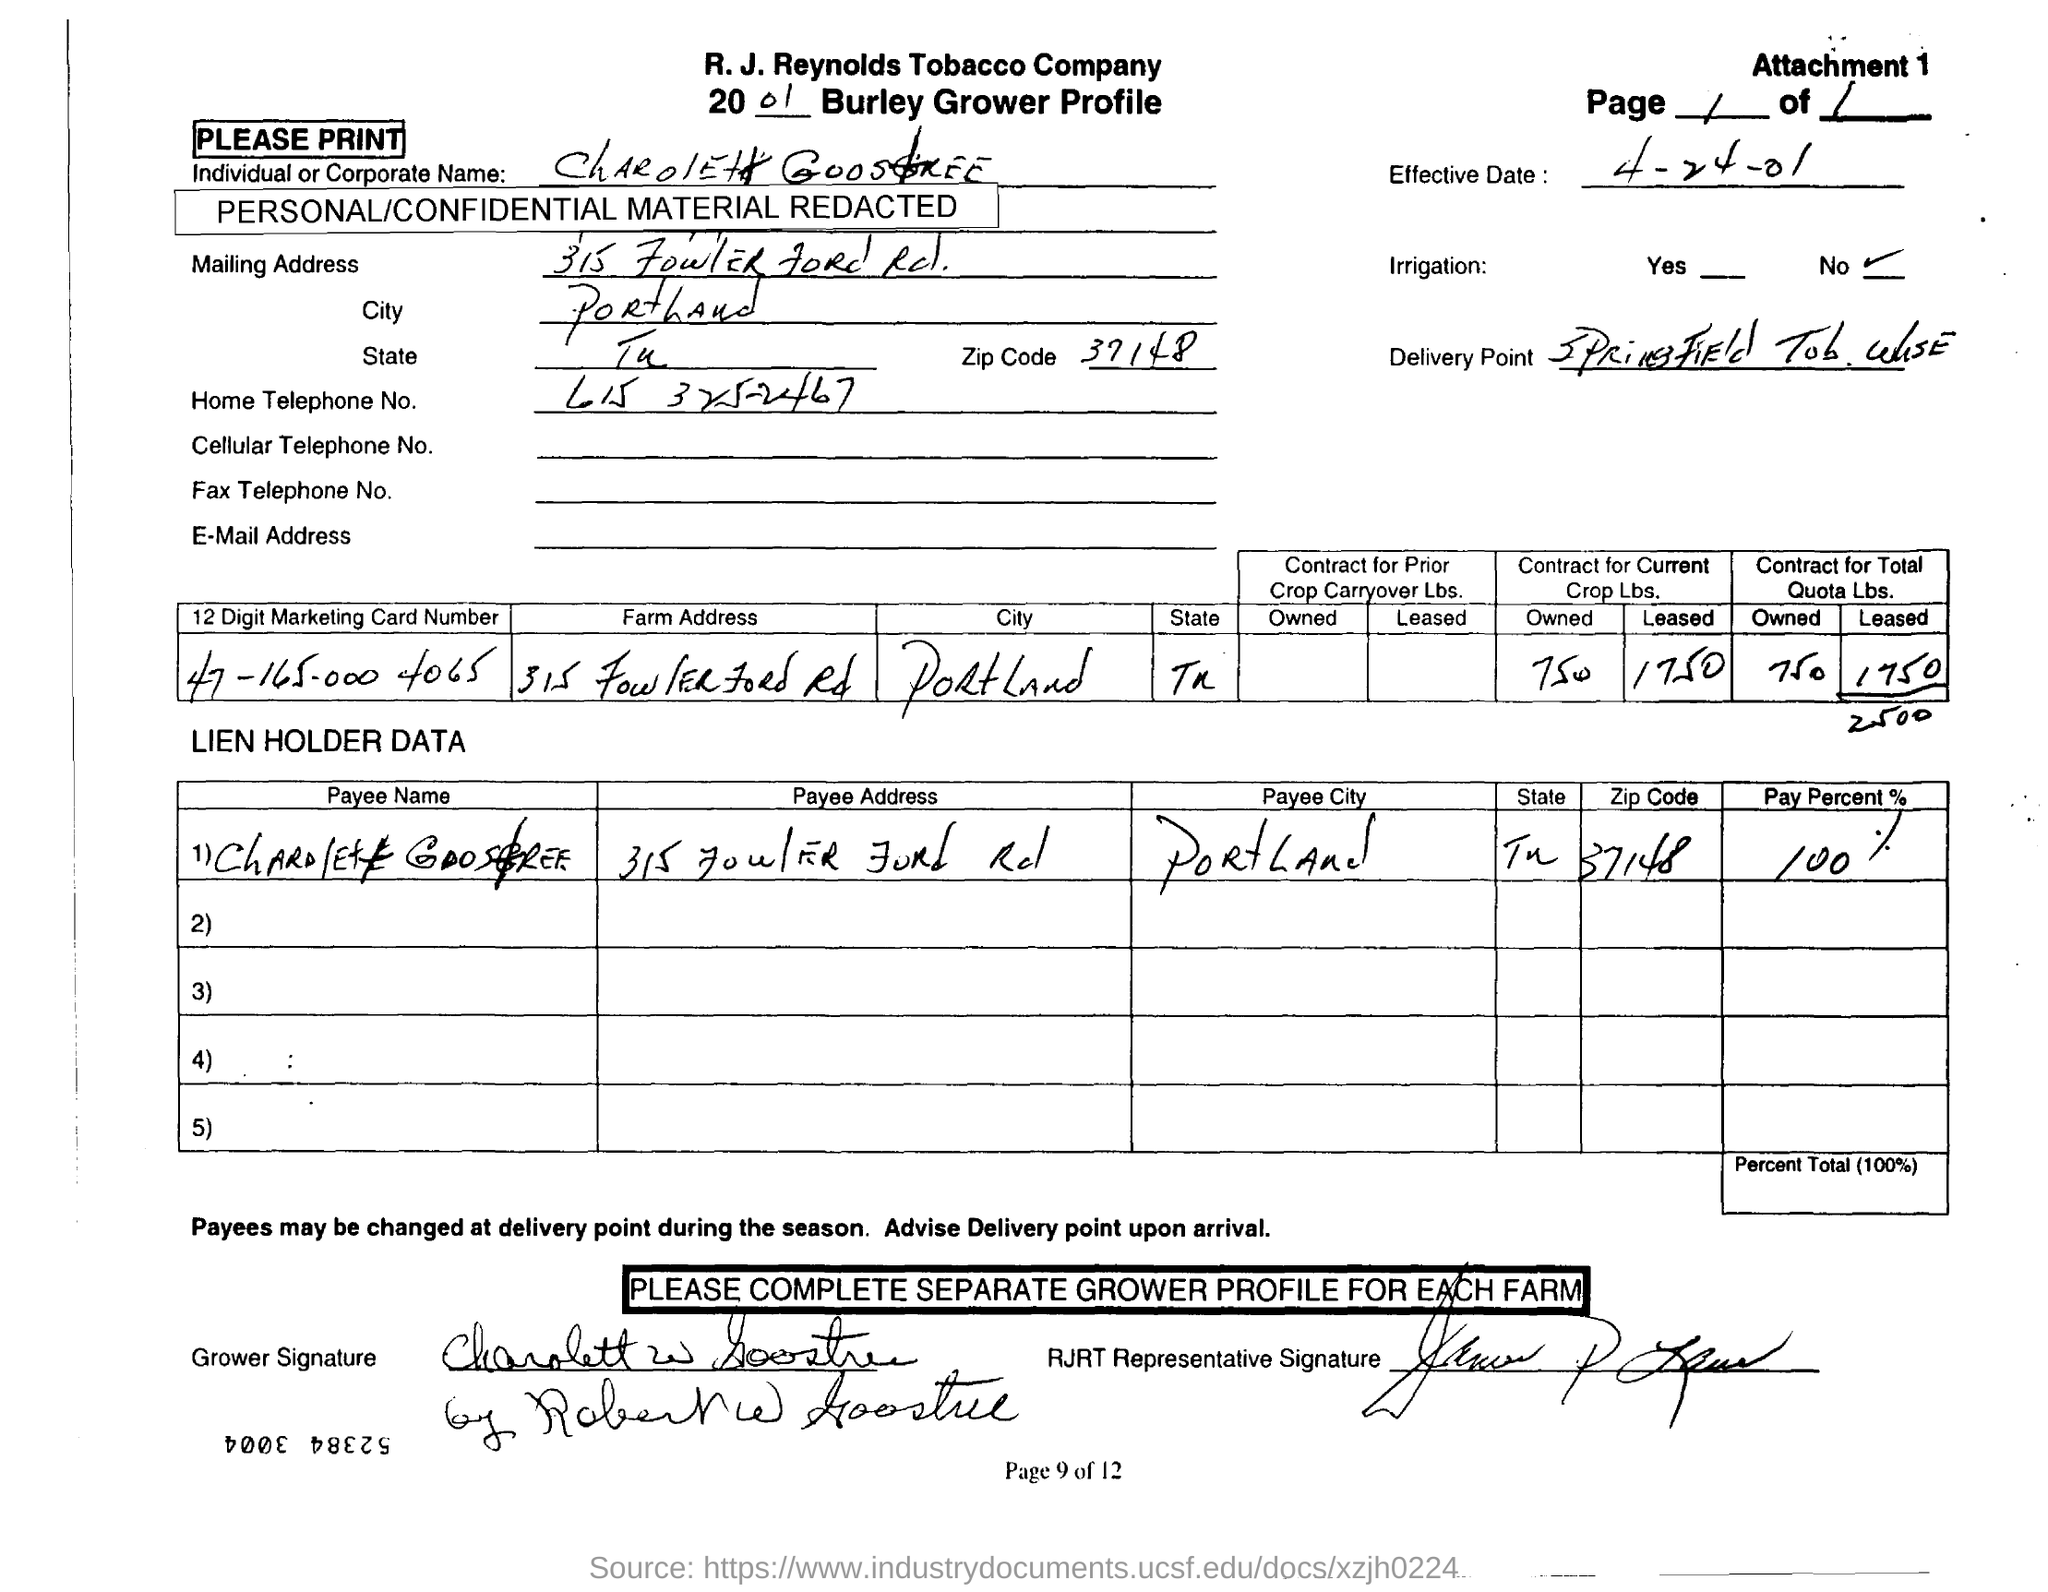Indicate a few pertinent items in this graphic. The home telephone number of Charlotte Goostree is 615-325-2467. The zip code associated with the provided address is 37148. The document mentions that the effective date is April 24, 2001. The Burley Grower Profile from 2001 lists a person named Charolett Goostree. The pay percentage mentioned in the document is 100%. 